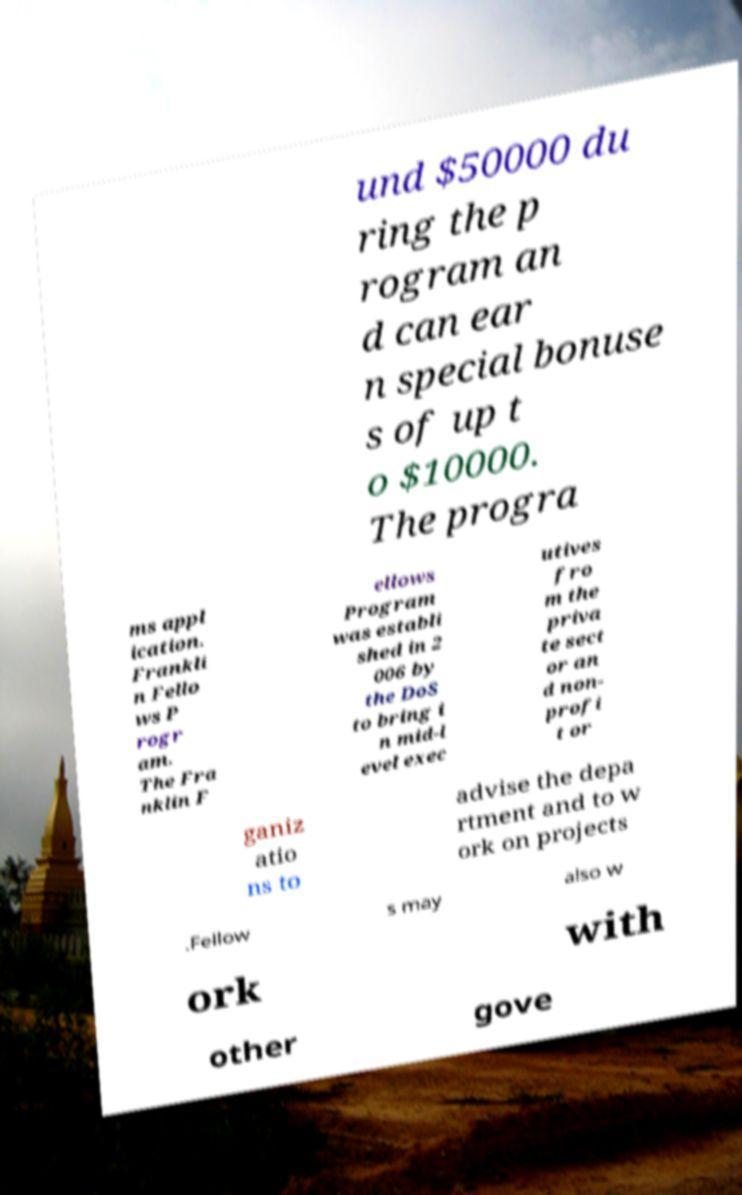For documentation purposes, I need the text within this image transcribed. Could you provide that? und $50000 du ring the p rogram an d can ear n special bonuse s of up t o $10000. The progra ms appl ication. Frankli n Fello ws P rogr am. The Fra nklin F ellows Program was establi shed in 2 006 by the DoS to bring i n mid-l evel exec utives fro m the priva te sect or an d non- profi t or ganiz atio ns to advise the depa rtment and to w ork on projects .Fellow s may also w ork with other gove 